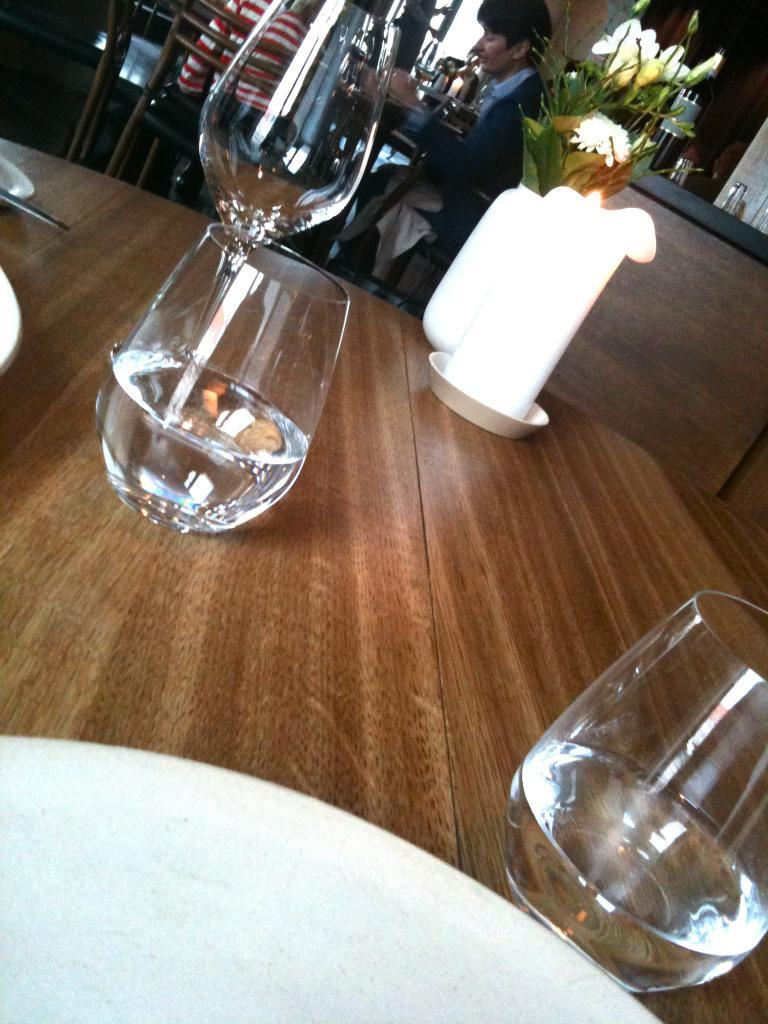What objects are on the table in the image? There are glasses, candles, a flower vase, and plates on the table. What else can be seen in the image besides the table? There is a person sitting at the back of the table, and there are chairs at the back of the table. How many objects are on the table? There are four objects on the table: glasses, candles, a flower vase, and plates. What type of machine is being used by the band in the image? There is no machine or band present in the image; it features a table with objects and a person sitting at the back. What is the wealth status of the person sitting at the table in the image? There is no information about the person's wealth status in the image. 